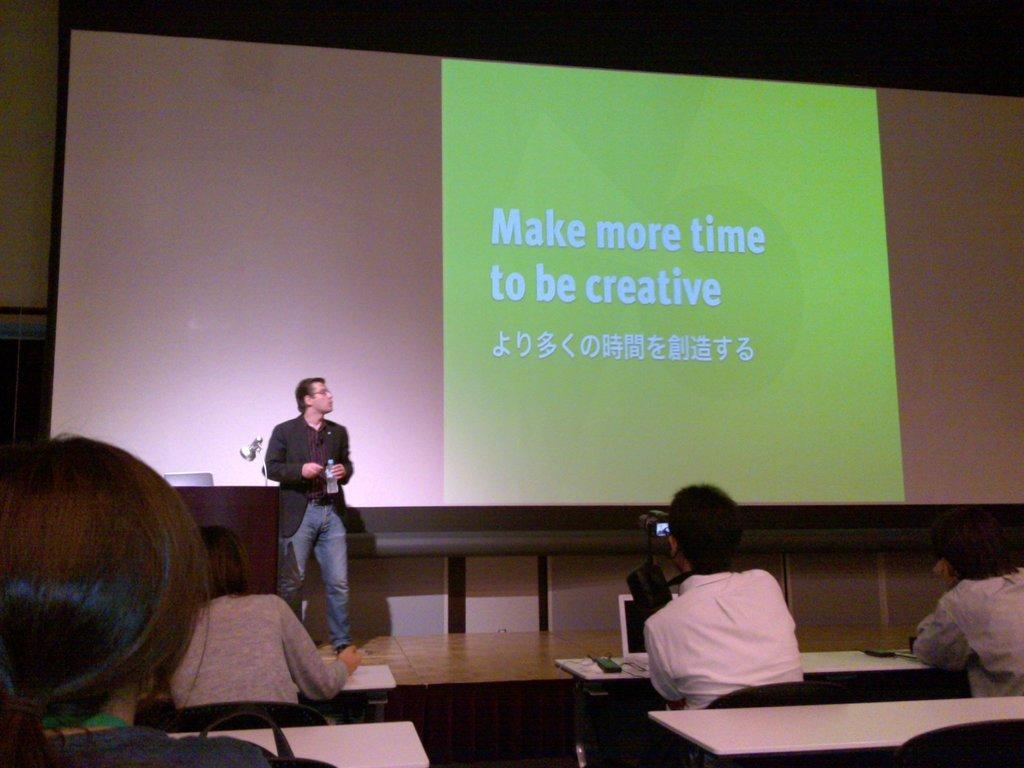<image>
Relay a brief, clear account of the picture shown. A PowerPoint open on a monitor that talks about creativity. 